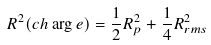<formula> <loc_0><loc_0><loc_500><loc_500>R ^ { 2 } ( c h \arg e ) = \frac { 1 } { 2 } R _ { p } ^ { 2 } + \frac { 1 } { 4 } R _ { r m s } ^ { 2 }</formula> 